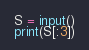<code> <loc_0><loc_0><loc_500><loc_500><_Python_>S = input()
print(S[:3])</code> 